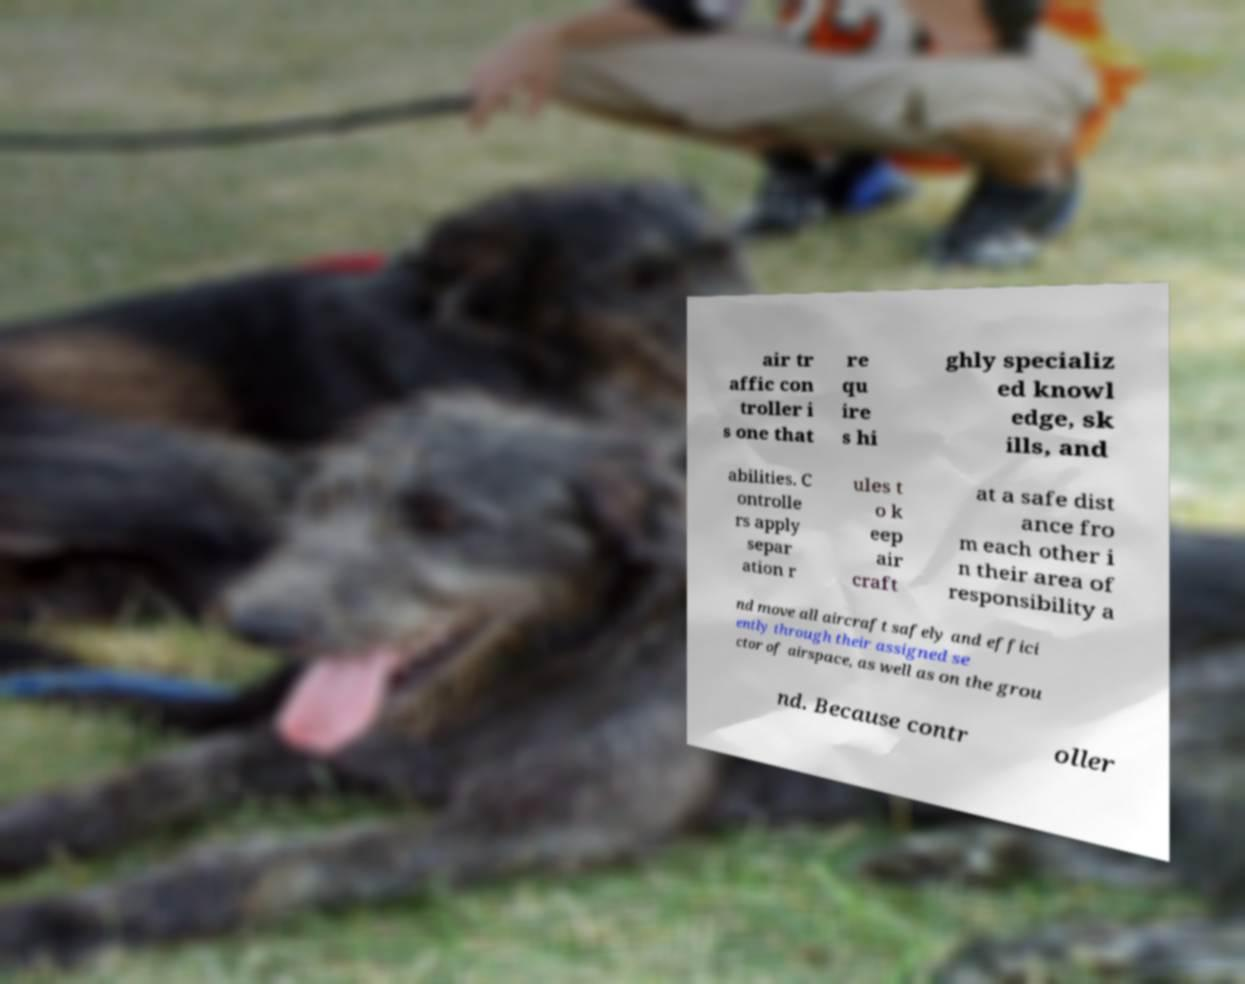Please read and relay the text visible in this image. What does it say? air tr affic con troller i s one that re qu ire s hi ghly specializ ed knowl edge, sk ills, and abilities. C ontrolle rs apply separ ation r ules t o k eep air craft at a safe dist ance fro m each other i n their area of responsibility a nd move all aircraft safely and effici ently through their assigned se ctor of airspace, as well as on the grou nd. Because contr oller 